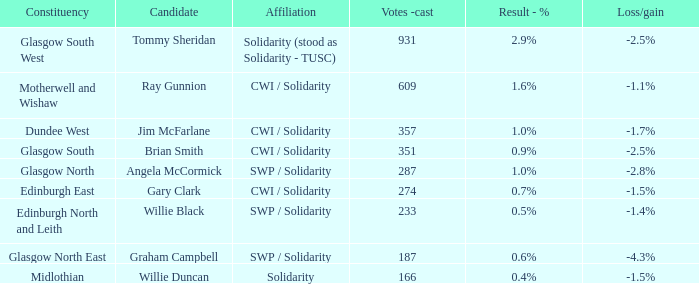Who as the candidate when the result - % was 2.9%? Tommy Sheridan. 